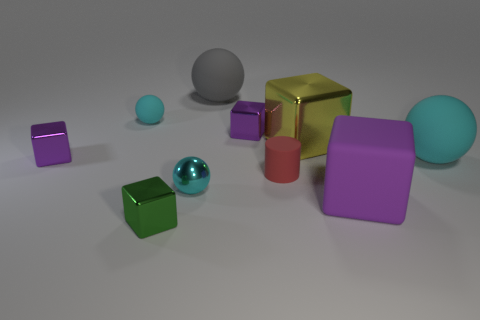Subtract all yellow cubes. How many cubes are left? 4 Subtract all large matte blocks. How many blocks are left? 4 Subtract all spheres. How many objects are left? 6 Subtract 2 spheres. How many spheres are left? 2 Add 8 tiny green blocks. How many tiny green blocks are left? 9 Add 9 tiny cyan matte spheres. How many tiny cyan matte spheres exist? 10 Subtract 0 cyan blocks. How many objects are left? 10 Subtract all purple cylinders. Subtract all red cubes. How many cylinders are left? 1 Subtract all red blocks. How many yellow balls are left? 0 Subtract all brown matte blocks. Subtract all cyan matte spheres. How many objects are left? 8 